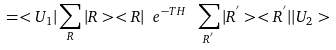Convert formula to latex. <formula><loc_0><loc_0><loc_500><loc_500>= < U _ { 1 } | \sum _ { R } | R > < R | \ e ^ { - T H } \ \sum _ { R ^ { ^ { \prime } } } | R ^ { ^ { \prime } } > < R ^ { ^ { \prime } } | | U _ { 2 } ></formula> 